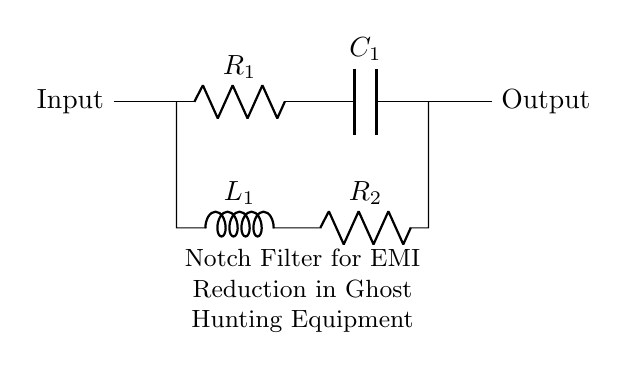What is the input of the circuit? The input of the circuit is indicated on the left side of the diagram. It shows a connection point labeled "Input."
Answer: Input What type of filter is displayed in the circuit? The circuit is identified as a notch filter, specifically designed for electromagnetic interference reduction, as noted in the description below the circuit.
Answer: Notch filter How many resistors are present in the circuit? The circuit diagram shows two components labeled as resistors, R1 and R2, indicating that there are two resistors in total.
Answer: 2 What is the role of the capacitor in this circuit? The capacitor, labeled C1, is intended to store and release electrical energy, which is a critical function for frequency filtering in a notch filter circuit.
Answer: Frequency filtering What is the significance of the inductor in this circuit? The inductor, labeled L1, plays a vital role in resonant circuits, improving the notch filter's ability to reject specific frequencies, and thereby reducing interference.
Answer: Rejecting frequencies Which components are in series in the upper branch? The upper branch of the circuit contains R1 and C1 in series, as both components are connected sequentially along the same path without any branching.
Answer: R1 and C1 What does the output represent in this circuit? The output is shown on the right side of the circuit diagram, indicating where the filtered signal leaves the circuit after passing through the notch filter.
Answer: Output 